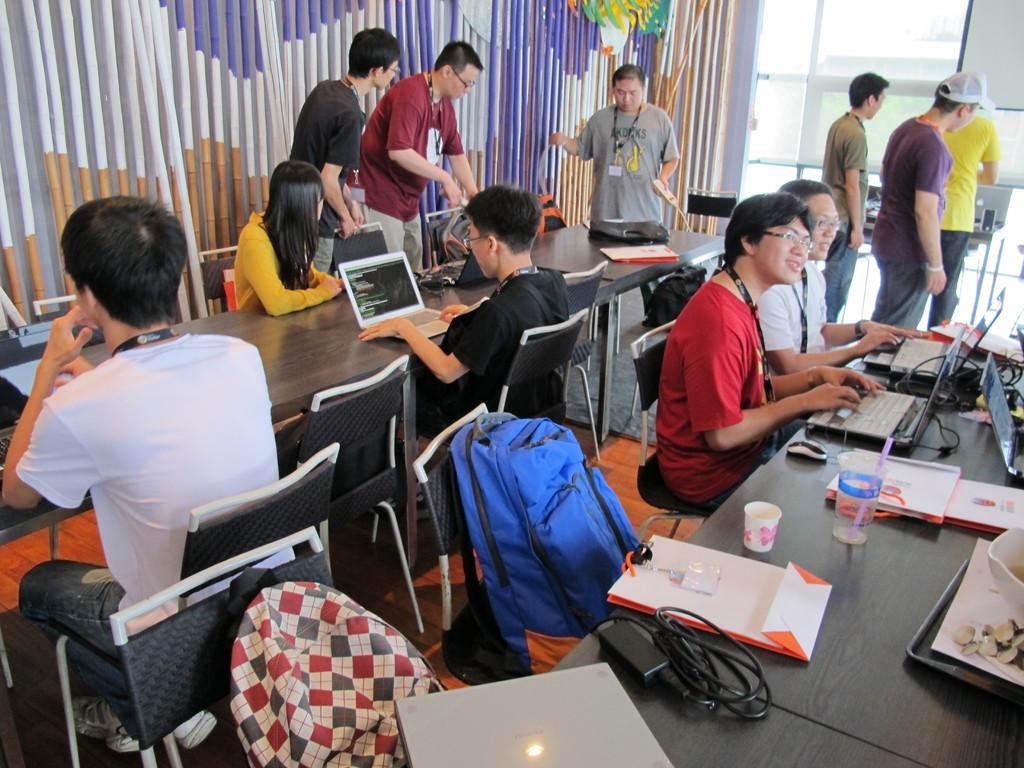In one or two sentences, can you explain what this image depicts? In this picture there are group of people, few are sitting and few are standing. There are laptops, cups, books, wires, mouses on the table. There are tables and chairs and there are bags on the chairs. At the back there is a door. 